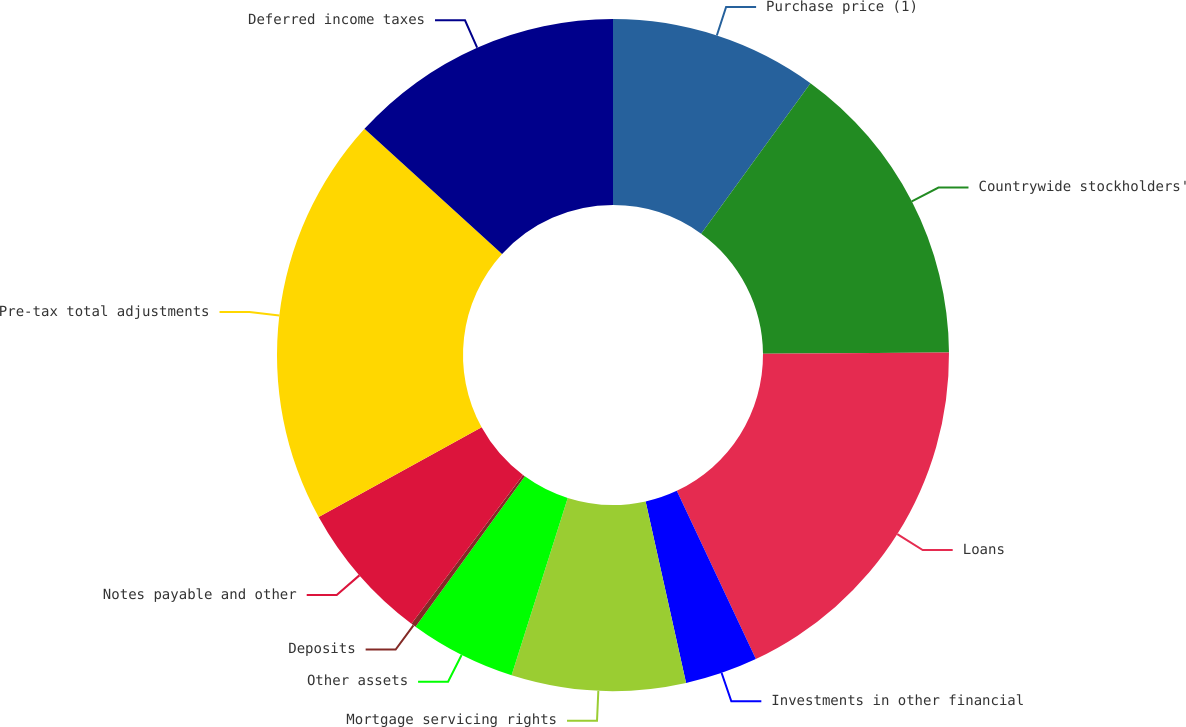<chart> <loc_0><loc_0><loc_500><loc_500><pie_chart><fcel>Purchase price (1)<fcel>Countrywide stockholders'<fcel>Loans<fcel>Investments in other financial<fcel>Mortgage servicing rights<fcel>Other assets<fcel>Deposits<fcel>Notes payable and other<fcel>Pre-tax total adjustments<fcel>Deferred income taxes<nl><fcel>10.0%<fcel>14.88%<fcel>18.13%<fcel>3.5%<fcel>8.37%<fcel>5.12%<fcel>0.24%<fcel>6.75%<fcel>19.76%<fcel>13.25%<nl></chart> 